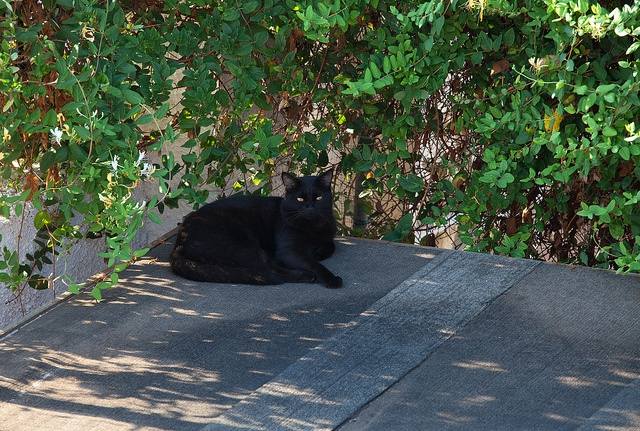Describe the objects in this image and their specific colors. I can see a cat in green, black, and gray tones in this image. 